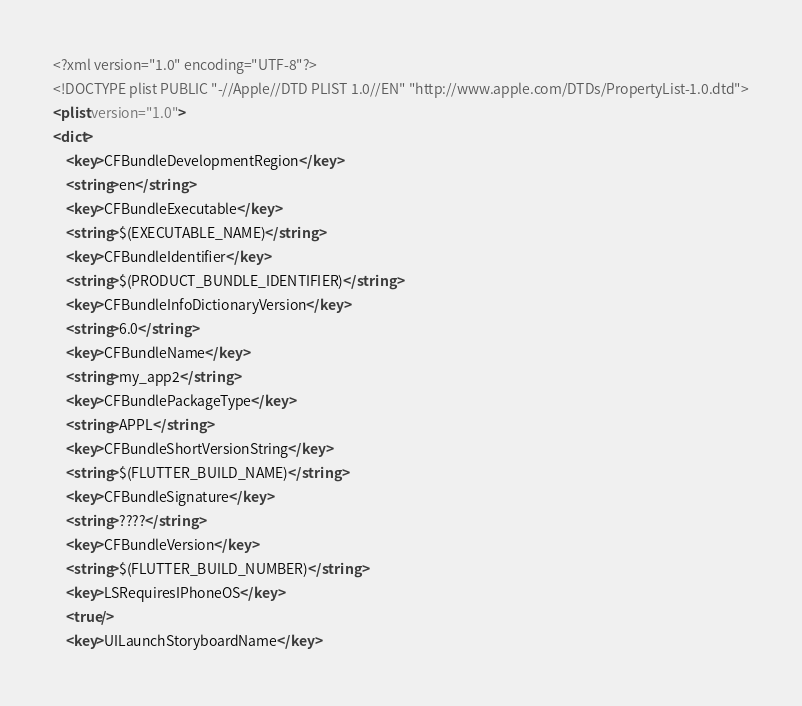Convert code to text. <code><loc_0><loc_0><loc_500><loc_500><_XML_><?xml version="1.0" encoding="UTF-8"?>
<!DOCTYPE plist PUBLIC "-//Apple//DTD PLIST 1.0//EN" "http://www.apple.com/DTDs/PropertyList-1.0.dtd">
<plist version="1.0">
<dict>
	<key>CFBundleDevelopmentRegion</key>
	<string>en</string>
	<key>CFBundleExecutable</key>
	<string>$(EXECUTABLE_NAME)</string>
	<key>CFBundleIdentifier</key>
	<string>$(PRODUCT_BUNDLE_IDENTIFIER)</string>
	<key>CFBundleInfoDictionaryVersion</key>
	<string>6.0</string>
	<key>CFBundleName</key>
	<string>my_app2</string>
	<key>CFBundlePackageType</key>
	<string>APPL</string>
	<key>CFBundleShortVersionString</key>
	<string>$(FLUTTER_BUILD_NAME)</string>
	<key>CFBundleSignature</key>
	<string>????</string>
	<key>CFBundleVersion</key>
	<string>$(FLUTTER_BUILD_NUMBER)</string>
	<key>LSRequiresIPhoneOS</key>
	<true/>
	<key>UILaunchStoryboardName</key></code> 